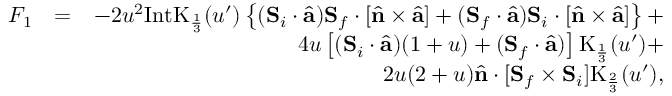Convert formula to latex. <formula><loc_0><loc_0><loc_500><loc_500>\begin{array} { r l r } { F _ { 1 } } & { = } & { - 2 u ^ { 2 } I n t K _ { \frac { 1 } { 3 } } ( u ^ { \prime } ) \left \{ ( { S } _ { i } \cdot \hat { a } ) { S } _ { f } \cdot \left [ \hat { n } \times \hat { a } \right ] + ( { S } _ { f } \cdot \hat { a } ) { S } _ { i } \cdot \left [ \hat { n } \times \hat { a } \right ] \right \} + } \\ & { 4 u \left [ ( { S } _ { i } \cdot \hat { a } ) ( 1 + u ) + ( { S } _ { f } \cdot \hat { a } ) \right ] K _ { \frac { 1 } { 3 } } ( u ^ { \prime } ) + } \\ & { 2 u ( 2 + u ) \hat { n } \cdot [ { S } _ { f } \times { S } _ { i } ] K _ { \frac { 2 } { 3 } } ( u ^ { \prime } ) , } \end{array}</formula> 